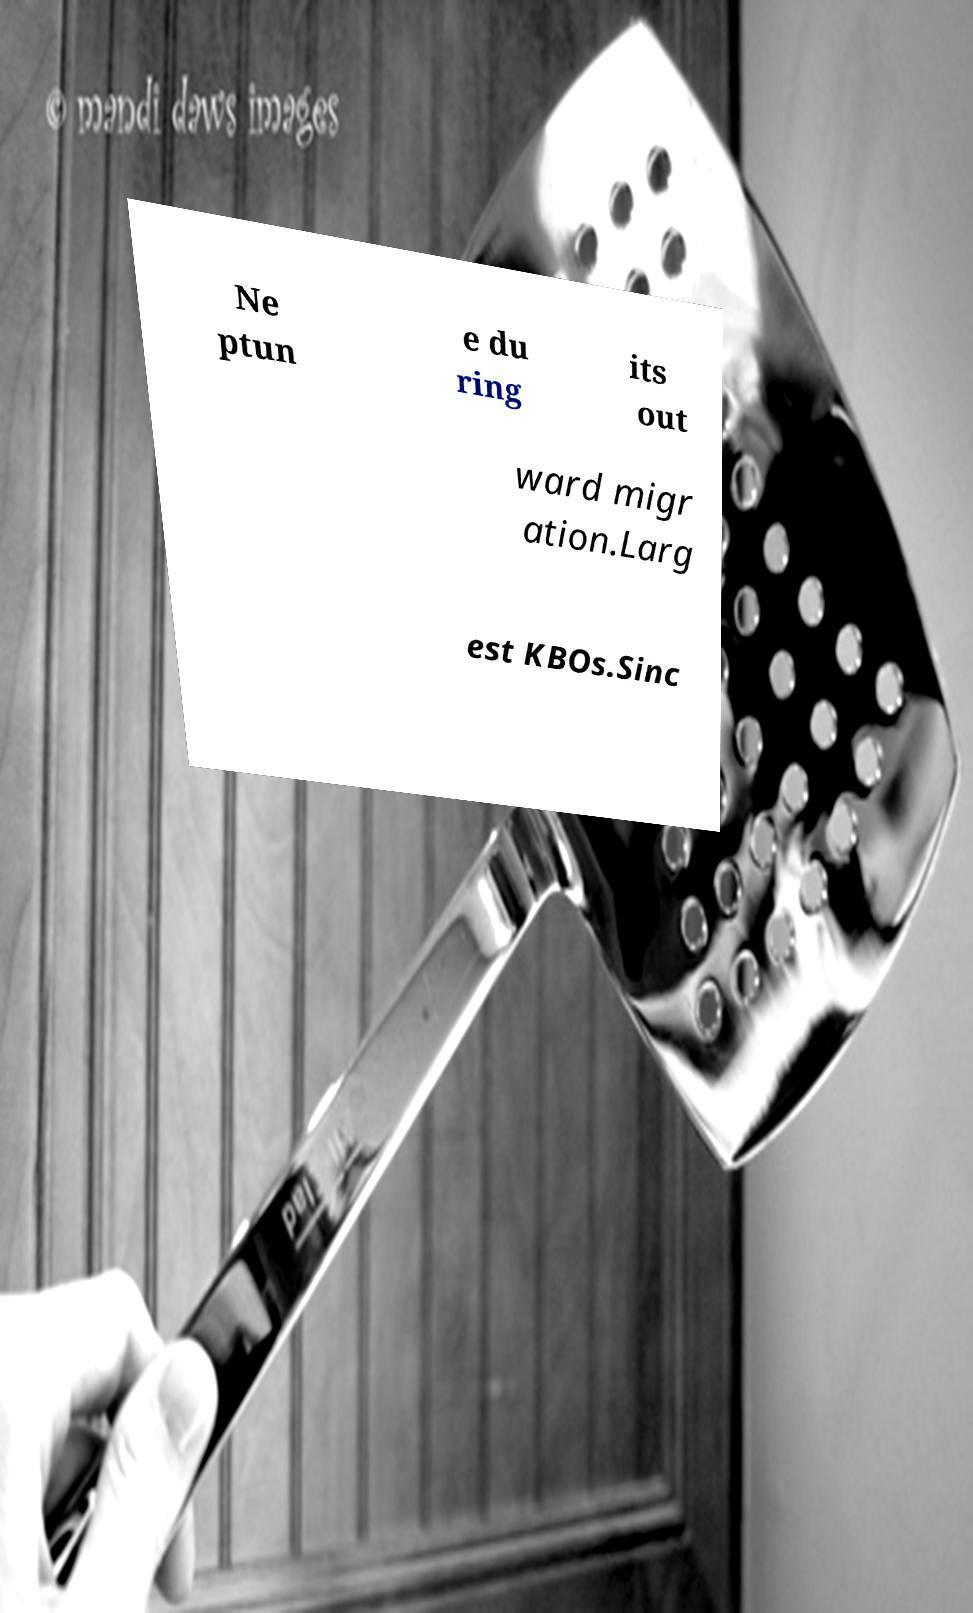For documentation purposes, I need the text within this image transcribed. Could you provide that? Ne ptun e du ring its out ward migr ation.Larg est KBOs.Sinc 